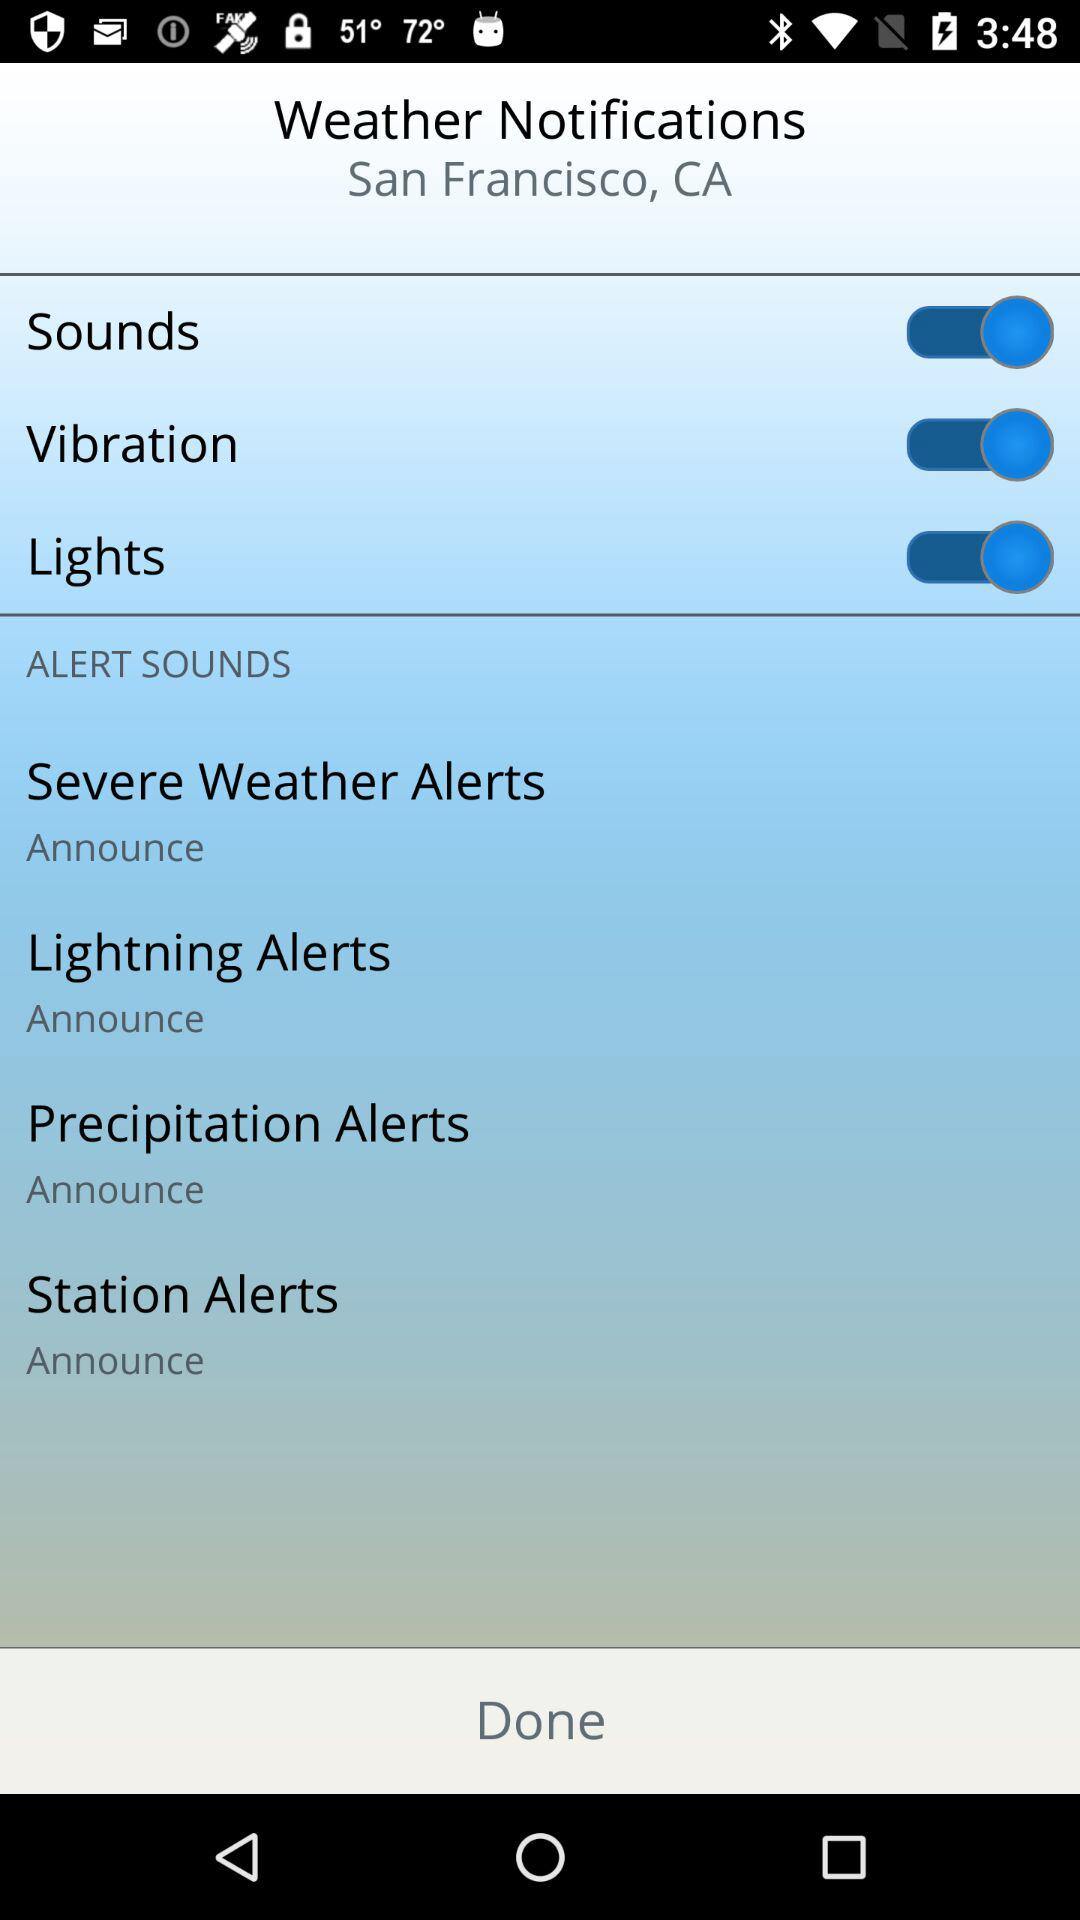What is the user's name?
When the provided information is insufficient, respond with <no answer>. <no answer> 